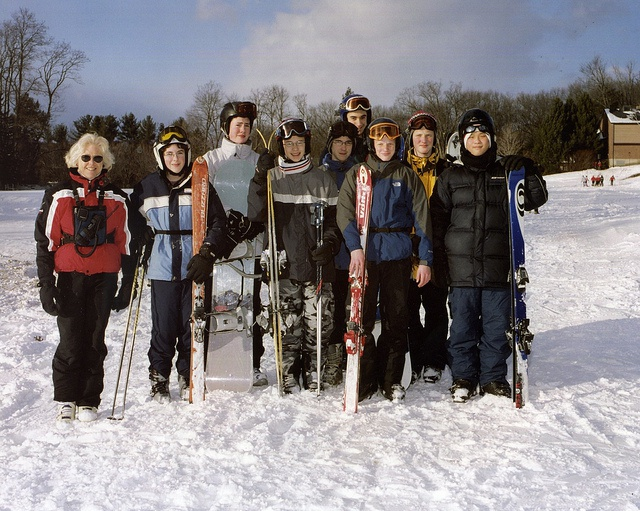Describe the objects in this image and their specific colors. I can see people in darkgray, black, maroon, brown, and lightgray tones, people in darkgray, black, navy, and gray tones, people in darkgray, black, and gray tones, people in darkgray, black, gray, and darkblue tones, and people in darkgray, black, gray, and lightgray tones in this image. 